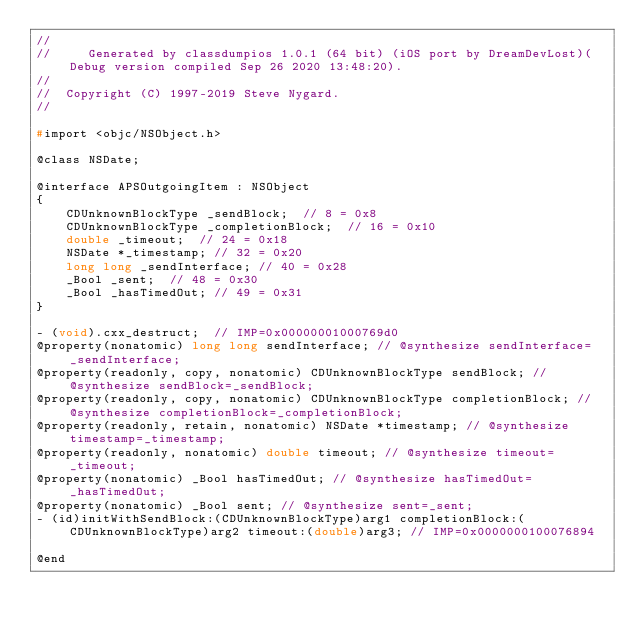<code> <loc_0><loc_0><loc_500><loc_500><_C_>//
//     Generated by classdumpios 1.0.1 (64 bit) (iOS port by DreamDevLost)(Debug version compiled Sep 26 2020 13:48:20).
//
//  Copyright (C) 1997-2019 Steve Nygard.
//

#import <objc/NSObject.h>

@class NSDate;

@interface APSOutgoingItem : NSObject
{
    CDUnknownBlockType _sendBlock;	// 8 = 0x8
    CDUnknownBlockType _completionBlock;	// 16 = 0x10
    double _timeout;	// 24 = 0x18
    NSDate *_timestamp;	// 32 = 0x20
    long long _sendInterface;	// 40 = 0x28
    _Bool _sent;	// 48 = 0x30
    _Bool _hasTimedOut;	// 49 = 0x31
}

- (void).cxx_destruct;	// IMP=0x00000001000769d0
@property(nonatomic) long long sendInterface; // @synthesize sendInterface=_sendInterface;
@property(readonly, copy, nonatomic) CDUnknownBlockType sendBlock; // @synthesize sendBlock=_sendBlock;
@property(readonly, copy, nonatomic) CDUnknownBlockType completionBlock; // @synthesize completionBlock=_completionBlock;
@property(readonly, retain, nonatomic) NSDate *timestamp; // @synthesize timestamp=_timestamp;
@property(readonly, nonatomic) double timeout; // @synthesize timeout=_timeout;
@property(nonatomic) _Bool hasTimedOut; // @synthesize hasTimedOut=_hasTimedOut;
@property(nonatomic) _Bool sent; // @synthesize sent=_sent;
- (id)initWithSendBlock:(CDUnknownBlockType)arg1 completionBlock:(CDUnknownBlockType)arg2 timeout:(double)arg3;	// IMP=0x0000000100076894

@end

</code> 